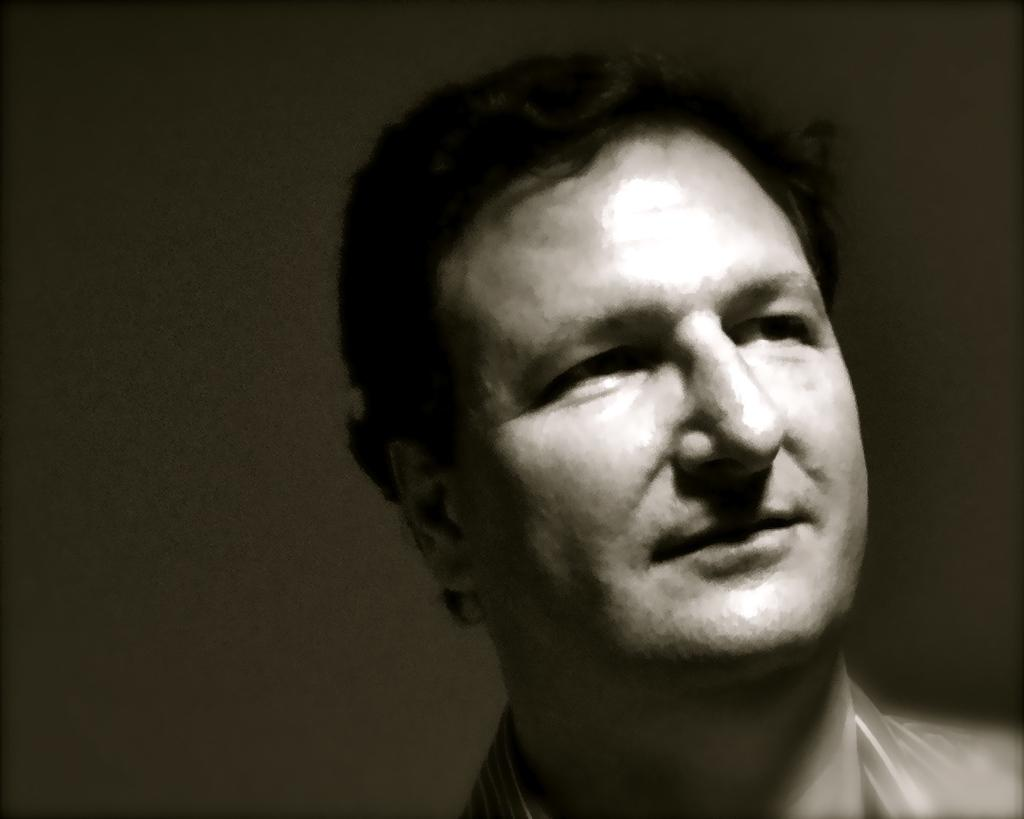Who is present in the image? There is a man in the picture. What is the man's facial expression in the image? The man is smiling. What color is the background of the image? The background of the image is black. What day of the week is the man celebrating in the image? The day of the week is not mentioned or depicted in the image, so it cannot be determined. 